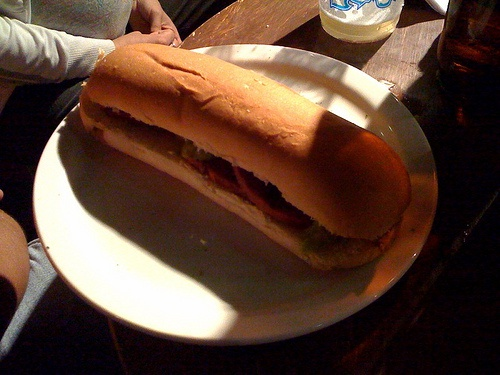Describe the objects in this image and their specific colors. I can see dining table in black, gray, maroon, ivory, and brown tones, hot dog in gray, maroon, black, orange, and brown tones, sandwich in gray, maroon, black, orange, and brown tones, people in black, gray, maroon, and beige tones, and bottle in gray, black, and maroon tones in this image. 